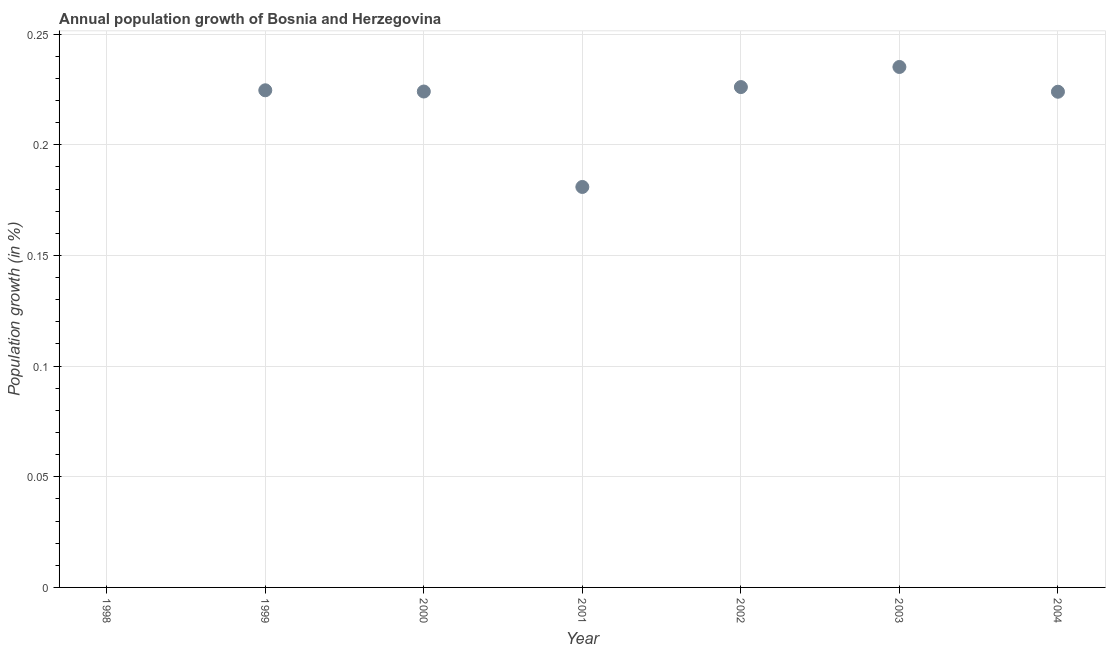What is the population growth in 2004?
Keep it short and to the point. 0.22. Across all years, what is the maximum population growth?
Your answer should be very brief. 0.24. What is the sum of the population growth?
Provide a succinct answer. 1.31. What is the difference between the population growth in 1999 and 2001?
Your answer should be very brief. 0.04. What is the average population growth per year?
Offer a terse response. 0.19. What is the median population growth?
Provide a succinct answer. 0.22. In how many years, is the population growth greater than 0.1 %?
Offer a very short reply. 6. What is the ratio of the population growth in 2002 to that in 2004?
Your answer should be very brief. 1.01. Is the population growth in 1999 less than that in 2003?
Provide a succinct answer. Yes. What is the difference between the highest and the second highest population growth?
Keep it short and to the point. 0.01. Is the sum of the population growth in 1999 and 2002 greater than the maximum population growth across all years?
Offer a very short reply. Yes. What is the difference between the highest and the lowest population growth?
Make the answer very short. 0.24. In how many years, is the population growth greater than the average population growth taken over all years?
Provide a short and direct response. 5. How many dotlines are there?
Offer a terse response. 1. How many years are there in the graph?
Your answer should be very brief. 7. What is the difference between two consecutive major ticks on the Y-axis?
Your response must be concise. 0.05. Are the values on the major ticks of Y-axis written in scientific E-notation?
Keep it short and to the point. No. Does the graph contain grids?
Offer a terse response. Yes. What is the title of the graph?
Provide a short and direct response. Annual population growth of Bosnia and Herzegovina. What is the label or title of the X-axis?
Your answer should be compact. Year. What is the label or title of the Y-axis?
Your response must be concise. Population growth (in %). What is the Population growth (in %) in 1998?
Keep it short and to the point. 0. What is the Population growth (in %) in 1999?
Your response must be concise. 0.22. What is the Population growth (in %) in 2000?
Make the answer very short. 0.22. What is the Population growth (in %) in 2001?
Offer a terse response. 0.18. What is the Population growth (in %) in 2002?
Ensure brevity in your answer.  0.23. What is the Population growth (in %) in 2003?
Make the answer very short. 0.24. What is the Population growth (in %) in 2004?
Your answer should be very brief. 0.22. What is the difference between the Population growth (in %) in 1999 and 2000?
Provide a short and direct response. 0. What is the difference between the Population growth (in %) in 1999 and 2001?
Offer a terse response. 0.04. What is the difference between the Population growth (in %) in 1999 and 2002?
Your response must be concise. -0. What is the difference between the Population growth (in %) in 1999 and 2003?
Provide a succinct answer. -0.01. What is the difference between the Population growth (in %) in 1999 and 2004?
Your answer should be compact. 0. What is the difference between the Population growth (in %) in 2000 and 2001?
Your response must be concise. 0.04. What is the difference between the Population growth (in %) in 2000 and 2002?
Your answer should be very brief. -0. What is the difference between the Population growth (in %) in 2000 and 2003?
Make the answer very short. -0.01. What is the difference between the Population growth (in %) in 2000 and 2004?
Ensure brevity in your answer.  0. What is the difference between the Population growth (in %) in 2001 and 2002?
Your answer should be very brief. -0.05. What is the difference between the Population growth (in %) in 2001 and 2003?
Keep it short and to the point. -0.05. What is the difference between the Population growth (in %) in 2001 and 2004?
Give a very brief answer. -0.04. What is the difference between the Population growth (in %) in 2002 and 2003?
Your answer should be compact. -0.01. What is the difference between the Population growth (in %) in 2002 and 2004?
Offer a very short reply. 0. What is the difference between the Population growth (in %) in 2003 and 2004?
Provide a succinct answer. 0.01. What is the ratio of the Population growth (in %) in 1999 to that in 2001?
Your response must be concise. 1.24. What is the ratio of the Population growth (in %) in 1999 to that in 2003?
Ensure brevity in your answer.  0.95. What is the ratio of the Population growth (in %) in 1999 to that in 2004?
Keep it short and to the point. 1. What is the ratio of the Population growth (in %) in 2000 to that in 2001?
Provide a short and direct response. 1.24. What is the ratio of the Population growth (in %) in 2000 to that in 2002?
Your response must be concise. 0.99. What is the ratio of the Population growth (in %) in 2000 to that in 2003?
Make the answer very short. 0.95. What is the ratio of the Population growth (in %) in 2000 to that in 2004?
Make the answer very short. 1. What is the ratio of the Population growth (in %) in 2001 to that in 2002?
Ensure brevity in your answer.  0.8. What is the ratio of the Population growth (in %) in 2001 to that in 2003?
Your answer should be very brief. 0.77. What is the ratio of the Population growth (in %) in 2001 to that in 2004?
Provide a succinct answer. 0.81. What is the ratio of the Population growth (in %) in 2002 to that in 2003?
Offer a terse response. 0.96. 